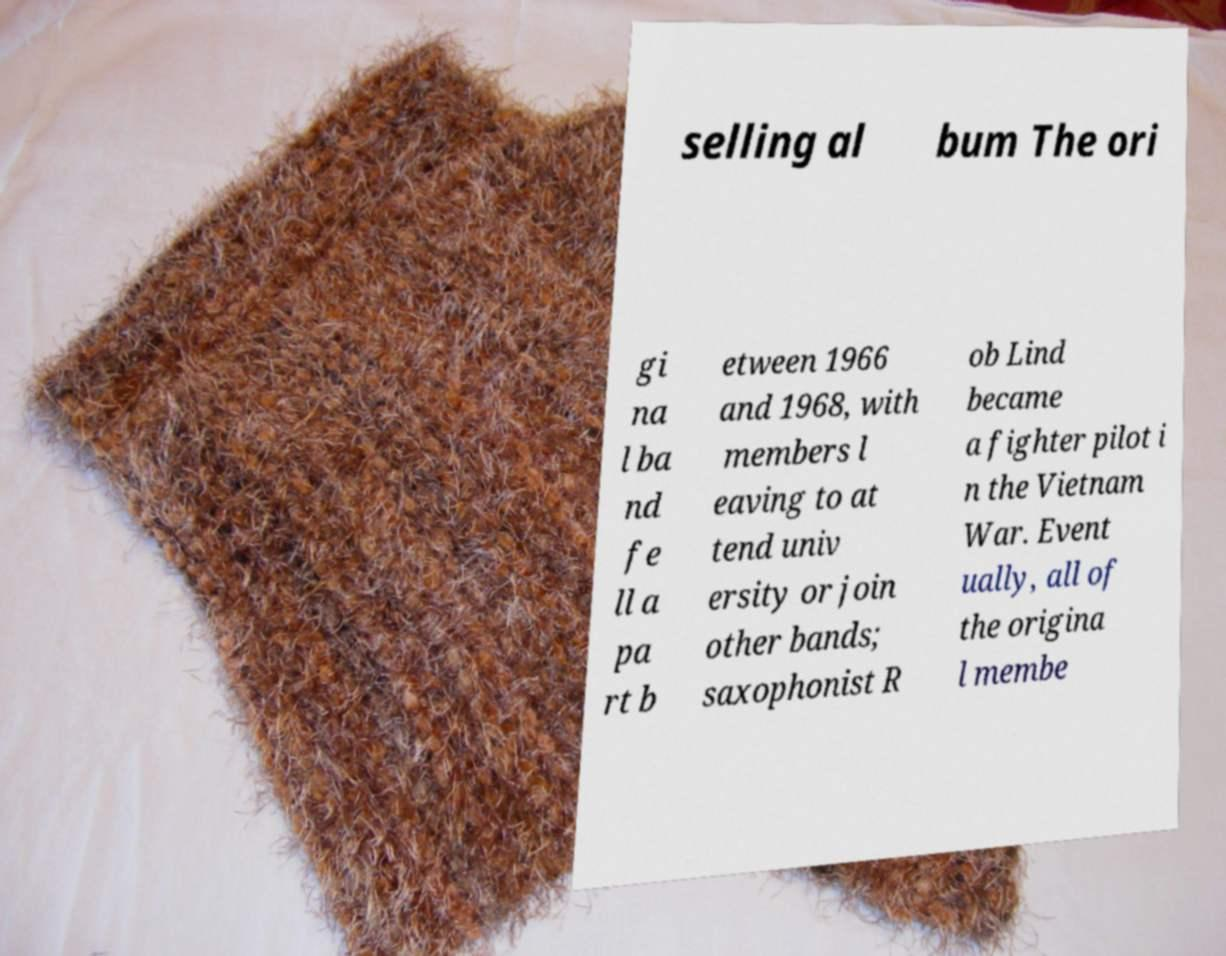For documentation purposes, I need the text within this image transcribed. Could you provide that? selling al bum The ori gi na l ba nd fe ll a pa rt b etween 1966 and 1968, with members l eaving to at tend univ ersity or join other bands; saxophonist R ob Lind became a fighter pilot i n the Vietnam War. Event ually, all of the origina l membe 